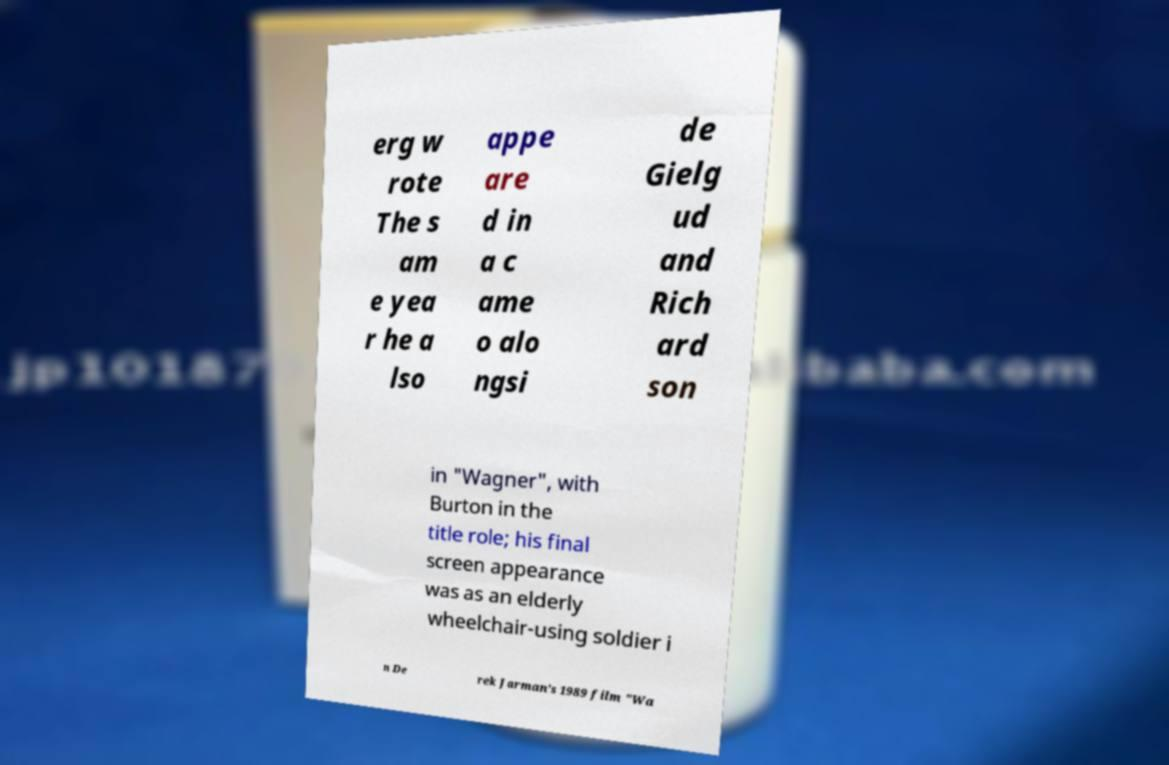Can you read and provide the text displayed in the image?This photo seems to have some interesting text. Can you extract and type it out for me? erg w rote The s am e yea r he a lso appe are d in a c ame o alo ngsi de Gielg ud and Rich ard son in "Wagner", with Burton in the title role; his final screen appearance was as an elderly wheelchair-using soldier i n De rek Jarman's 1989 film "Wa 